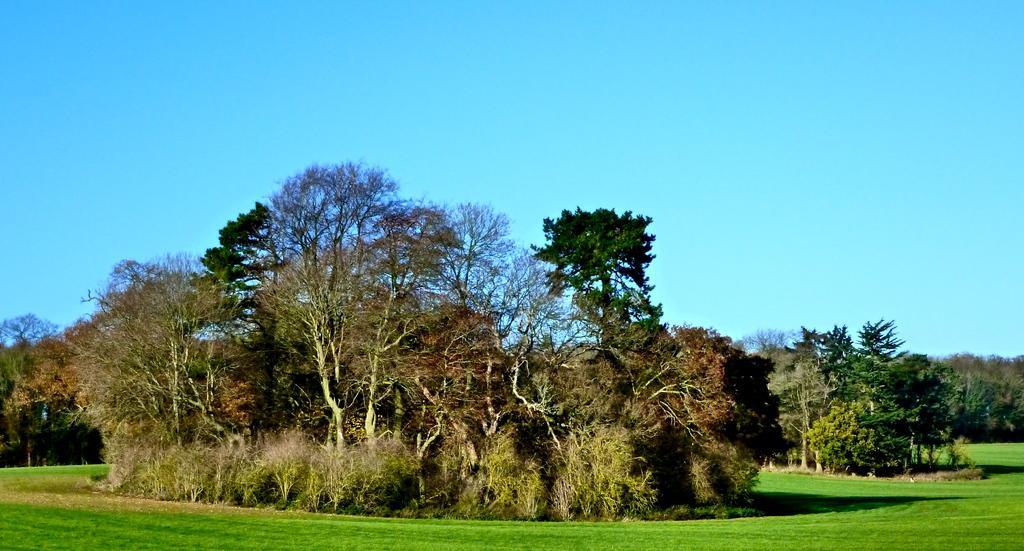How would you summarize this image in a sentence or two? In the picture we can see a grass surface on it, we can see a group of plants and trees and behind it, we can see many trees and top of it we can see the sky which is blue in color. 